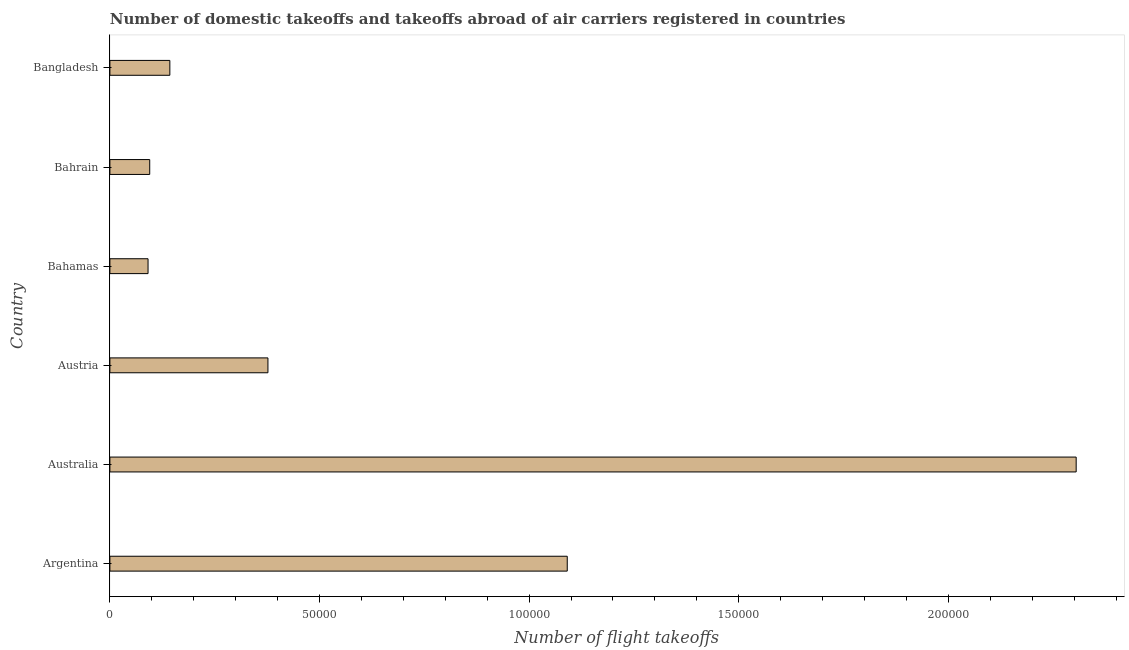What is the title of the graph?
Your response must be concise. Number of domestic takeoffs and takeoffs abroad of air carriers registered in countries. What is the label or title of the X-axis?
Your answer should be compact. Number of flight takeoffs. What is the number of flight takeoffs in Austria?
Your answer should be very brief. 3.77e+04. Across all countries, what is the maximum number of flight takeoffs?
Your answer should be compact. 2.30e+05. Across all countries, what is the minimum number of flight takeoffs?
Give a very brief answer. 9100. In which country was the number of flight takeoffs minimum?
Your answer should be very brief. Bahamas. What is the sum of the number of flight takeoffs?
Offer a terse response. 4.10e+05. What is the difference between the number of flight takeoffs in Argentina and Australia?
Ensure brevity in your answer.  -1.21e+05. What is the average number of flight takeoffs per country?
Your response must be concise. 6.84e+04. What is the median number of flight takeoffs?
Provide a short and direct response. 2.60e+04. In how many countries, is the number of flight takeoffs greater than 110000 ?
Offer a very short reply. 1. What is the ratio of the number of flight takeoffs in Argentina to that in Bahamas?
Offer a very short reply. 11.99. Is the number of flight takeoffs in Argentina less than that in Austria?
Your answer should be very brief. No. Is the difference between the number of flight takeoffs in Bahamas and Bahrain greater than the difference between any two countries?
Provide a succinct answer. No. What is the difference between the highest and the second highest number of flight takeoffs?
Your answer should be very brief. 1.21e+05. What is the difference between the highest and the lowest number of flight takeoffs?
Give a very brief answer. 2.21e+05. Are all the bars in the graph horizontal?
Your answer should be very brief. Yes. How many countries are there in the graph?
Your answer should be very brief. 6. What is the Number of flight takeoffs of Argentina?
Give a very brief answer. 1.09e+05. What is the Number of flight takeoffs of Australia?
Your answer should be very brief. 2.30e+05. What is the Number of flight takeoffs of Austria?
Offer a terse response. 3.77e+04. What is the Number of flight takeoffs of Bahamas?
Your answer should be compact. 9100. What is the Number of flight takeoffs in Bahrain?
Offer a terse response. 9500. What is the Number of flight takeoffs in Bangladesh?
Keep it short and to the point. 1.43e+04. What is the difference between the Number of flight takeoffs in Argentina and Australia?
Ensure brevity in your answer.  -1.21e+05. What is the difference between the Number of flight takeoffs in Argentina and Austria?
Provide a succinct answer. 7.14e+04. What is the difference between the Number of flight takeoffs in Argentina and Bahrain?
Your answer should be compact. 9.96e+04. What is the difference between the Number of flight takeoffs in Argentina and Bangladesh?
Provide a short and direct response. 9.48e+04. What is the difference between the Number of flight takeoffs in Australia and Austria?
Ensure brevity in your answer.  1.93e+05. What is the difference between the Number of flight takeoffs in Australia and Bahamas?
Provide a short and direct response. 2.21e+05. What is the difference between the Number of flight takeoffs in Australia and Bahrain?
Make the answer very short. 2.21e+05. What is the difference between the Number of flight takeoffs in Australia and Bangladesh?
Offer a very short reply. 2.16e+05. What is the difference between the Number of flight takeoffs in Austria and Bahamas?
Your answer should be very brief. 2.86e+04. What is the difference between the Number of flight takeoffs in Austria and Bahrain?
Your answer should be very brief. 2.82e+04. What is the difference between the Number of flight takeoffs in Austria and Bangladesh?
Make the answer very short. 2.34e+04. What is the difference between the Number of flight takeoffs in Bahamas and Bahrain?
Your response must be concise. -400. What is the difference between the Number of flight takeoffs in Bahamas and Bangladesh?
Your answer should be compact. -5200. What is the difference between the Number of flight takeoffs in Bahrain and Bangladesh?
Provide a short and direct response. -4800. What is the ratio of the Number of flight takeoffs in Argentina to that in Australia?
Give a very brief answer. 0.47. What is the ratio of the Number of flight takeoffs in Argentina to that in Austria?
Provide a succinct answer. 2.89. What is the ratio of the Number of flight takeoffs in Argentina to that in Bahamas?
Your answer should be compact. 11.99. What is the ratio of the Number of flight takeoffs in Argentina to that in Bahrain?
Your answer should be very brief. 11.48. What is the ratio of the Number of flight takeoffs in Argentina to that in Bangladesh?
Offer a terse response. 7.63. What is the ratio of the Number of flight takeoffs in Australia to that in Austria?
Give a very brief answer. 6.11. What is the ratio of the Number of flight takeoffs in Australia to that in Bahamas?
Ensure brevity in your answer.  25.33. What is the ratio of the Number of flight takeoffs in Australia to that in Bahrain?
Provide a short and direct response. 24.26. What is the ratio of the Number of flight takeoffs in Australia to that in Bangladesh?
Your response must be concise. 16.12. What is the ratio of the Number of flight takeoffs in Austria to that in Bahamas?
Ensure brevity in your answer.  4.14. What is the ratio of the Number of flight takeoffs in Austria to that in Bahrain?
Ensure brevity in your answer.  3.97. What is the ratio of the Number of flight takeoffs in Austria to that in Bangladesh?
Your response must be concise. 2.64. What is the ratio of the Number of flight takeoffs in Bahamas to that in Bahrain?
Provide a succinct answer. 0.96. What is the ratio of the Number of flight takeoffs in Bahamas to that in Bangladesh?
Your answer should be compact. 0.64. What is the ratio of the Number of flight takeoffs in Bahrain to that in Bangladesh?
Make the answer very short. 0.66. 